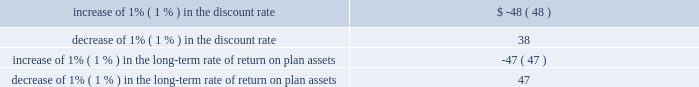The aes corporation notes to consolidated financial statements 2014 ( continued ) december 31 , 2012 , 2011 , and 2010 ( 1 ) a u.s .
Subsidiary of the company has a defined benefit obligation of $ 764 million and $ 679 million as of december 31 , 2012 and 2011 , respectively , and uses salary bands to determine future benefit costs rather than rates of compensation increases .
Rates of compensation increases in the table above do not include amounts related to this specific defined benefit plan .
( 2 ) includes an inflation factor that is used to calculate future periodic benefit cost , but is not used to calculate the benefit obligation .
The company establishes its estimated long-term return on plan assets considering various factors , which include the targeted asset allocation percentages , historic returns and expected future returns .
The measurement of pension obligations , costs and liabilities is dependent on a variety of assumptions .
These assumptions include estimates of the present value of projected future pension payments to all plan participants , taking into consideration the likelihood of potential future events such as salary increases and demographic experience .
These assumptions may have an effect on the amount and timing of future contributions .
The assumptions used in developing the required estimates include the following key factors : 2022 discount rates ; 2022 salary growth ; 2022 retirement rates ; 2022 inflation ; 2022 expected return on plan assets ; and 2022 mortality rates .
The effects of actual results differing from the company 2019s assumptions are accumulated and amortized over future periods and , therefore , generally affect the company 2019s recognized expense in such future periods .
Sensitivity of the company 2019s pension funded status to the indicated increase or decrease in the discount rate and long-term rate of return on plan assets assumptions is shown below .
Note that these sensitivities may be asymmetric and are specific to the base conditions at year-end 2012 .
They also may not be additive , so the impact of changing multiple factors simultaneously cannot be calculated by combining the individual sensitivities shown .
The funded status as of december 31 , 2012 is affected by the assumptions as of that date .
Pension expense for 2012 is affected by the december 31 , 2011 assumptions .
The impact on pension expense from a one percentage point change in these assumptions is shown in the table below ( in millions ) : .

What was the net reduction in defined benefit obligations between december 31 , 2012 and 2011 , in millions? 
Computations: (764 - 679)
Answer: 85.0. The aes corporation notes to consolidated financial statements 2014 ( continued ) december 31 , 2012 , 2011 , and 2010 ( 1 ) a u.s .
Subsidiary of the company has a defined benefit obligation of $ 764 million and $ 679 million as of december 31 , 2012 and 2011 , respectively , and uses salary bands to determine future benefit costs rather than rates of compensation increases .
Rates of compensation increases in the table above do not include amounts related to this specific defined benefit plan .
( 2 ) includes an inflation factor that is used to calculate future periodic benefit cost , but is not used to calculate the benefit obligation .
The company establishes its estimated long-term return on plan assets considering various factors , which include the targeted asset allocation percentages , historic returns and expected future returns .
The measurement of pension obligations , costs and liabilities is dependent on a variety of assumptions .
These assumptions include estimates of the present value of projected future pension payments to all plan participants , taking into consideration the likelihood of potential future events such as salary increases and demographic experience .
These assumptions may have an effect on the amount and timing of future contributions .
The assumptions used in developing the required estimates include the following key factors : 2022 discount rates ; 2022 salary growth ; 2022 retirement rates ; 2022 inflation ; 2022 expected return on plan assets ; and 2022 mortality rates .
The effects of actual results differing from the company 2019s assumptions are accumulated and amortized over future periods and , therefore , generally affect the company 2019s recognized expense in such future periods .
Sensitivity of the company 2019s pension funded status to the indicated increase or decrease in the discount rate and long-term rate of return on plan assets assumptions is shown below .
Note that these sensitivities may be asymmetric and are specific to the base conditions at year-end 2012 .
They also may not be additive , so the impact of changing multiple factors simultaneously cannot be calculated by combining the individual sensitivities shown .
The funded status as of december 31 , 2012 is affected by the assumptions as of that date .
Pension expense for 2012 is affected by the december 31 , 2011 assumptions .
The impact on pension expense from a one percentage point change in these assumptions is shown in the table below ( in millions ) : .

Was the impact of a decrease of 1% ( 1 % ) in the discount rate greater than the effect of a decrease of 1% ( 1 % ) in the long-term rate of return on plan assets? 
Computations: (38 > 47)
Answer: no. 